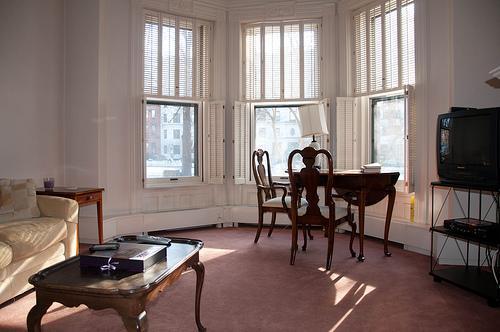How many chairs are visible?
Give a very brief answer. 2. How many windows are there?
Give a very brief answer. 3. 